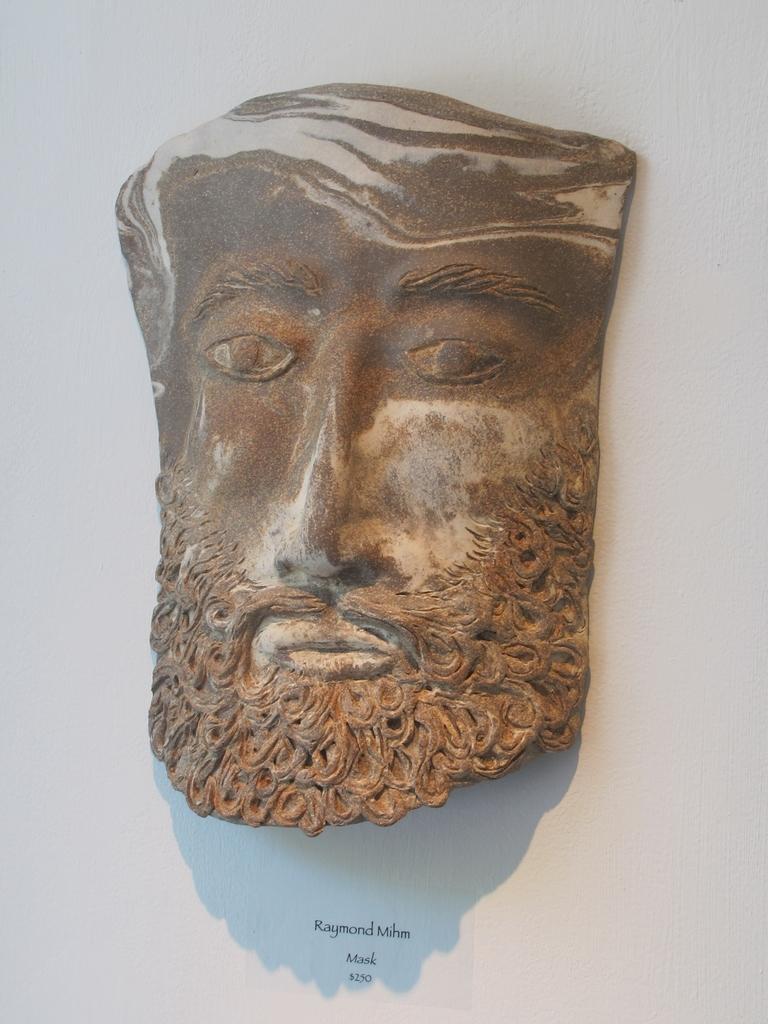Describe this image in one or two sentences. In this image I can see the carved rock which is in the shape of human face. I can see the white background. 